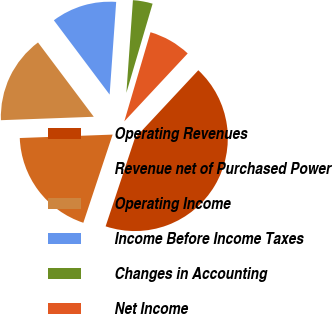<chart> <loc_0><loc_0><loc_500><loc_500><pie_chart><fcel>Operating Revenues<fcel>Revenue net of Purchased Power<fcel>Operating Income<fcel>Income Before Income Taxes<fcel>Changes in Accounting<fcel>Net Income<nl><fcel>43.15%<fcel>19.31%<fcel>15.34%<fcel>11.37%<fcel>3.43%<fcel>7.4%<nl></chart> 